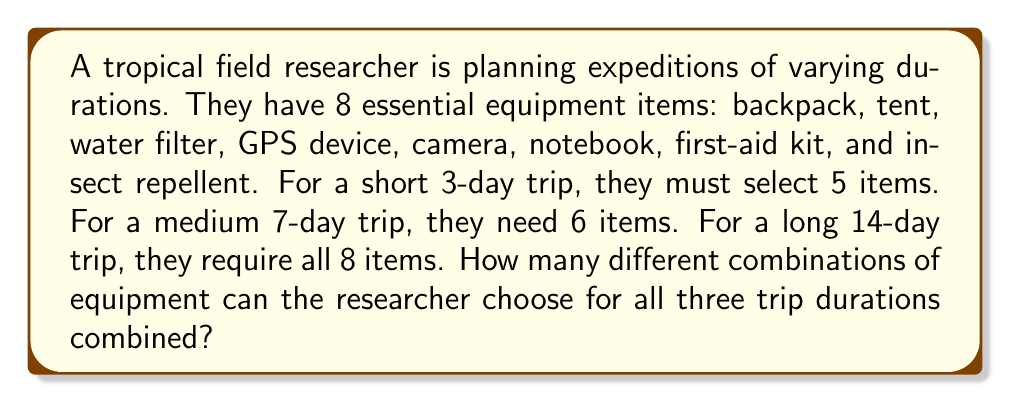Could you help me with this problem? Let's break this down step-by-step:

1) For the 3-day trip (5 items out of 8):
   This is a combination problem, denoted as $\binom{8}{5}$
   $$\binom{8}{5} = \frac{8!}{5!(8-5)!} = \frac{8!}{5!3!} = 56$$

2) For the 7-day trip (6 items out of 8):
   This is a combination problem, denoted as $\binom{8}{6}$
   $$\binom{8}{6} = \frac{8!}{6!(8-6)!} = \frac{8!}{6!2!} = 28$$

3) For the 14-day trip (all 8 items):
   There's only one way to choose all 8 items, so this is just 1 combination.

4) To find the total number of combinations for all three trip durations, we sum the results:
   $$56 + 28 + 1 = 85$$

Therefore, the total number of different combinations of equipment the researcher can choose for all three trip durations combined is 85.
Answer: 85 combinations 